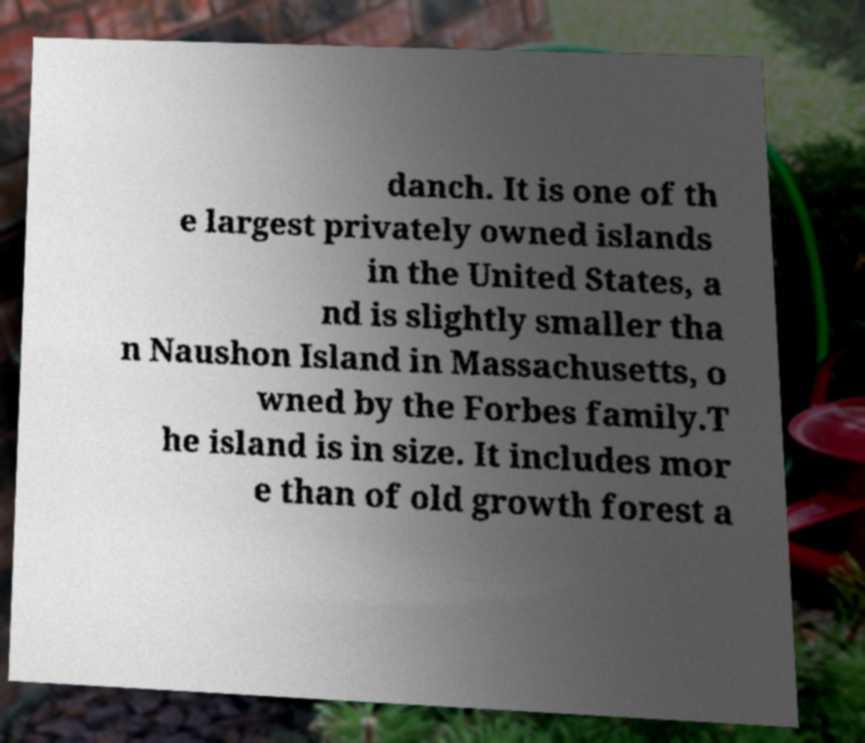Please identify and transcribe the text found in this image. danch. It is one of th e largest privately owned islands in the United States, a nd is slightly smaller tha n Naushon Island in Massachusetts, o wned by the Forbes family.T he island is in size. It includes mor e than of old growth forest a 